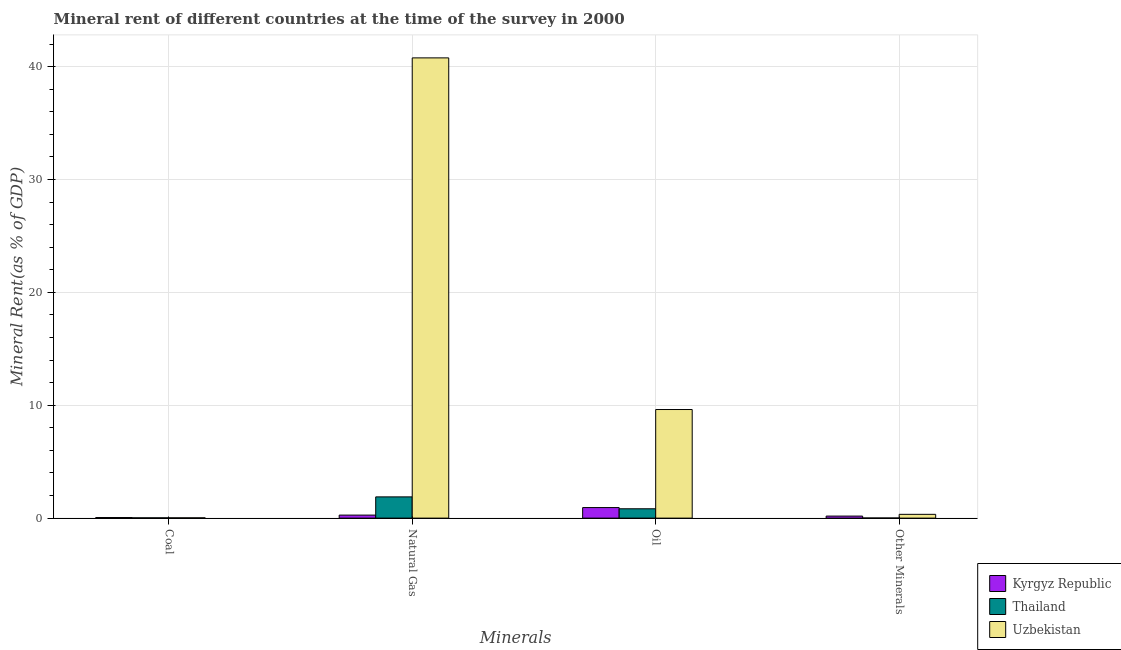How many different coloured bars are there?
Offer a terse response. 3. How many groups of bars are there?
Your answer should be compact. 4. Are the number of bars per tick equal to the number of legend labels?
Your answer should be very brief. Yes. Are the number of bars on each tick of the X-axis equal?
Your response must be concise. Yes. What is the label of the 3rd group of bars from the left?
Your answer should be very brief. Oil. What is the natural gas rent in Uzbekistan?
Provide a short and direct response. 40.78. Across all countries, what is the maximum coal rent?
Your answer should be very brief. 0.05. Across all countries, what is the minimum oil rent?
Make the answer very short. 0.83. In which country was the oil rent maximum?
Offer a very short reply. Uzbekistan. In which country was the oil rent minimum?
Offer a terse response. Thailand. What is the total  rent of other minerals in the graph?
Offer a terse response. 0.52. What is the difference between the natural gas rent in Thailand and that in Uzbekistan?
Your response must be concise. -38.9. What is the difference between the oil rent in Uzbekistan and the  rent of other minerals in Kyrgyz Republic?
Your answer should be very brief. 9.44. What is the average natural gas rent per country?
Offer a very short reply. 14.31. What is the difference between the  rent of other minerals and natural gas rent in Kyrgyz Republic?
Offer a very short reply. -0.09. In how many countries, is the oil rent greater than 36 %?
Ensure brevity in your answer.  0. What is the ratio of the oil rent in Thailand to that in Uzbekistan?
Your response must be concise. 0.09. Is the difference between the natural gas rent in Uzbekistan and Kyrgyz Republic greater than the difference between the coal rent in Uzbekistan and Kyrgyz Republic?
Your answer should be compact. Yes. What is the difference between the highest and the second highest oil rent?
Your response must be concise. 8.69. What is the difference between the highest and the lowest oil rent?
Your answer should be compact. 8.79. In how many countries, is the  rent of other minerals greater than the average  rent of other minerals taken over all countries?
Your answer should be compact. 2. What does the 2nd bar from the left in Oil represents?
Offer a very short reply. Thailand. What does the 3rd bar from the right in Oil represents?
Offer a very short reply. Kyrgyz Republic. Is it the case that in every country, the sum of the coal rent and natural gas rent is greater than the oil rent?
Make the answer very short. No. How many bars are there?
Provide a succinct answer. 12. What is the difference between two consecutive major ticks on the Y-axis?
Make the answer very short. 10. How many legend labels are there?
Your answer should be compact. 3. How are the legend labels stacked?
Ensure brevity in your answer.  Vertical. What is the title of the graph?
Keep it short and to the point. Mineral rent of different countries at the time of the survey in 2000. Does "Swaziland" appear as one of the legend labels in the graph?
Your answer should be very brief. No. What is the label or title of the X-axis?
Give a very brief answer. Minerals. What is the label or title of the Y-axis?
Offer a very short reply. Mineral Rent(as % of GDP). What is the Mineral Rent(as % of GDP) in Kyrgyz Republic in Coal?
Offer a terse response. 0.05. What is the Mineral Rent(as % of GDP) of Thailand in Coal?
Your answer should be very brief. 0.03. What is the Mineral Rent(as % of GDP) of Uzbekistan in Coal?
Ensure brevity in your answer.  0.03. What is the Mineral Rent(as % of GDP) of Kyrgyz Republic in Natural Gas?
Your answer should be compact. 0.27. What is the Mineral Rent(as % of GDP) of Thailand in Natural Gas?
Provide a succinct answer. 1.88. What is the Mineral Rent(as % of GDP) of Uzbekistan in Natural Gas?
Your response must be concise. 40.78. What is the Mineral Rent(as % of GDP) of Kyrgyz Republic in Oil?
Give a very brief answer. 0.94. What is the Mineral Rent(as % of GDP) of Thailand in Oil?
Offer a very short reply. 0.83. What is the Mineral Rent(as % of GDP) of Uzbekistan in Oil?
Offer a very short reply. 9.62. What is the Mineral Rent(as % of GDP) in Kyrgyz Republic in Other Minerals?
Your answer should be compact. 0.18. What is the Mineral Rent(as % of GDP) in Thailand in Other Minerals?
Ensure brevity in your answer.  0.01. What is the Mineral Rent(as % of GDP) in Uzbekistan in Other Minerals?
Keep it short and to the point. 0.34. Across all Minerals, what is the maximum Mineral Rent(as % of GDP) of Kyrgyz Republic?
Provide a succinct answer. 0.94. Across all Minerals, what is the maximum Mineral Rent(as % of GDP) in Thailand?
Your response must be concise. 1.88. Across all Minerals, what is the maximum Mineral Rent(as % of GDP) of Uzbekistan?
Your response must be concise. 40.78. Across all Minerals, what is the minimum Mineral Rent(as % of GDP) in Kyrgyz Republic?
Your response must be concise. 0.05. Across all Minerals, what is the minimum Mineral Rent(as % of GDP) in Thailand?
Keep it short and to the point. 0.01. Across all Minerals, what is the minimum Mineral Rent(as % of GDP) of Uzbekistan?
Offer a terse response. 0.03. What is the total Mineral Rent(as % of GDP) in Kyrgyz Republic in the graph?
Provide a short and direct response. 1.43. What is the total Mineral Rent(as % of GDP) of Thailand in the graph?
Your answer should be very brief. 2.74. What is the total Mineral Rent(as % of GDP) of Uzbekistan in the graph?
Provide a short and direct response. 50.77. What is the difference between the Mineral Rent(as % of GDP) of Kyrgyz Republic in Coal and that in Natural Gas?
Your answer should be very brief. -0.22. What is the difference between the Mineral Rent(as % of GDP) in Thailand in Coal and that in Natural Gas?
Your answer should be very brief. -1.86. What is the difference between the Mineral Rent(as % of GDP) in Uzbekistan in Coal and that in Natural Gas?
Offer a terse response. -40.76. What is the difference between the Mineral Rent(as % of GDP) in Kyrgyz Republic in Coal and that in Oil?
Your answer should be very brief. -0.88. What is the difference between the Mineral Rent(as % of GDP) of Thailand in Coal and that in Oil?
Provide a succinct answer. -0.8. What is the difference between the Mineral Rent(as % of GDP) in Uzbekistan in Coal and that in Oil?
Your response must be concise. -9.6. What is the difference between the Mineral Rent(as % of GDP) in Kyrgyz Republic in Coal and that in Other Minerals?
Your answer should be compact. -0.13. What is the difference between the Mineral Rent(as % of GDP) of Thailand in Coal and that in Other Minerals?
Offer a terse response. 0.02. What is the difference between the Mineral Rent(as % of GDP) in Uzbekistan in Coal and that in Other Minerals?
Provide a succinct answer. -0.31. What is the difference between the Mineral Rent(as % of GDP) in Kyrgyz Republic in Natural Gas and that in Oil?
Make the answer very short. -0.67. What is the difference between the Mineral Rent(as % of GDP) of Thailand in Natural Gas and that in Oil?
Offer a very short reply. 1.05. What is the difference between the Mineral Rent(as % of GDP) of Uzbekistan in Natural Gas and that in Oil?
Provide a succinct answer. 31.16. What is the difference between the Mineral Rent(as % of GDP) of Kyrgyz Republic in Natural Gas and that in Other Minerals?
Give a very brief answer. 0.09. What is the difference between the Mineral Rent(as % of GDP) of Thailand in Natural Gas and that in Other Minerals?
Your answer should be very brief. 1.87. What is the difference between the Mineral Rent(as % of GDP) of Uzbekistan in Natural Gas and that in Other Minerals?
Your response must be concise. 40.45. What is the difference between the Mineral Rent(as % of GDP) of Kyrgyz Republic in Oil and that in Other Minerals?
Ensure brevity in your answer.  0.76. What is the difference between the Mineral Rent(as % of GDP) of Thailand in Oil and that in Other Minerals?
Keep it short and to the point. 0.82. What is the difference between the Mineral Rent(as % of GDP) of Uzbekistan in Oil and that in Other Minerals?
Your response must be concise. 9.29. What is the difference between the Mineral Rent(as % of GDP) in Kyrgyz Republic in Coal and the Mineral Rent(as % of GDP) in Thailand in Natural Gas?
Give a very brief answer. -1.83. What is the difference between the Mineral Rent(as % of GDP) of Kyrgyz Republic in Coal and the Mineral Rent(as % of GDP) of Uzbekistan in Natural Gas?
Your answer should be compact. -40.73. What is the difference between the Mineral Rent(as % of GDP) in Thailand in Coal and the Mineral Rent(as % of GDP) in Uzbekistan in Natural Gas?
Make the answer very short. -40.76. What is the difference between the Mineral Rent(as % of GDP) of Kyrgyz Republic in Coal and the Mineral Rent(as % of GDP) of Thailand in Oil?
Give a very brief answer. -0.78. What is the difference between the Mineral Rent(as % of GDP) of Kyrgyz Republic in Coal and the Mineral Rent(as % of GDP) of Uzbekistan in Oil?
Offer a terse response. -9.57. What is the difference between the Mineral Rent(as % of GDP) in Thailand in Coal and the Mineral Rent(as % of GDP) in Uzbekistan in Oil?
Give a very brief answer. -9.6. What is the difference between the Mineral Rent(as % of GDP) in Kyrgyz Republic in Coal and the Mineral Rent(as % of GDP) in Thailand in Other Minerals?
Your answer should be compact. 0.04. What is the difference between the Mineral Rent(as % of GDP) of Kyrgyz Republic in Coal and the Mineral Rent(as % of GDP) of Uzbekistan in Other Minerals?
Your answer should be very brief. -0.28. What is the difference between the Mineral Rent(as % of GDP) of Thailand in Coal and the Mineral Rent(as % of GDP) of Uzbekistan in Other Minerals?
Provide a short and direct response. -0.31. What is the difference between the Mineral Rent(as % of GDP) of Kyrgyz Republic in Natural Gas and the Mineral Rent(as % of GDP) of Thailand in Oil?
Your response must be concise. -0.56. What is the difference between the Mineral Rent(as % of GDP) of Kyrgyz Republic in Natural Gas and the Mineral Rent(as % of GDP) of Uzbekistan in Oil?
Keep it short and to the point. -9.35. What is the difference between the Mineral Rent(as % of GDP) of Thailand in Natural Gas and the Mineral Rent(as % of GDP) of Uzbekistan in Oil?
Offer a terse response. -7.74. What is the difference between the Mineral Rent(as % of GDP) in Kyrgyz Republic in Natural Gas and the Mineral Rent(as % of GDP) in Thailand in Other Minerals?
Your answer should be very brief. 0.26. What is the difference between the Mineral Rent(as % of GDP) of Kyrgyz Republic in Natural Gas and the Mineral Rent(as % of GDP) of Uzbekistan in Other Minerals?
Keep it short and to the point. -0.07. What is the difference between the Mineral Rent(as % of GDP) of Thailand in Natural Gas and the Mineral Rent(as % of GDP) of Uzbekistan in Other Minerals?
Your answer should be compact. 1.55. What is the difference between the Mineral Rent(as % of GDP) of Kyrgyz Republic in Oil and the Mineral Rent(as % of GDP) of Thailand in Other Minerals?
Your answer should be very brief. 0.93. What is the difference between the Mineral Rent(as % of GDP) in Kyrgyz Republic in Oil and the Mineral Rent(as % of GDP) in Uzbekistan in Other Minerals?
Provide a succinct answer. 0.6. What is the difference between the Mineral Rent(as % of GDP) of Thailand in Oil and the Mineral Rent(as % of GDP) of Uzbekistan in Other Minerals?
Make the answer very short. 0.49. What is the average Mineral Rent(as % of GDP) of Kyrgyz Republic per Minerals?
Give a very brief answer. 0.36. What is the average Mineral Rent(as % of GDP) of Thailand per Minerals?
Keep it short and to the point. 0.69. What is the average Mineral Rent(as % of GDP) of Uzbekistan per Minerals?
Offer a very short reply. 12.69. What is the difference between the Mineral Rent(as % of GDP) of Kyrgyz Republic and Mineral Rent(as % of GDP) of Thailand in Coal?
Your answer should be compact. 0.03. What is the difference between the Mineral Rent(as % of GDP) in Kyrgyz Republic and Mineral Rent(as % of GDP) in Uzbekistan in Coal?
Ensure brevity in your answer.  0.03. What is the difference between the Mineral Rent(as % of GDP) of Thailand and Mineral Rent(as % of GDP) of Uzbekistan in Coal?
Give a very brief answer. -0. What is the difference between the Mineral Rent(as % of GDP) of Kyrgyz Republic and Mineral Rent(as % of GDP) of Thailand in Natural Gas?
Provide a succinct answer. -1.61. What is the difference between the Mineral Rent(as % of GDP) of Kyrgyz Republic and Mineral Rent(as % of GDP) of Uzbekistan in Natural Gas?
Offer a very short reply. -40.52. What is the difference between the Mineral Rent(as % of GDP) of Thailand and Mineral Rent(as % of GDP) of Uzbekistan in Natural Gas?
Offer a terse response. -38.9. What is the difference between the Mineral Rent(as % of GDP) in Kyrgyz Republic and Mineral Rent(as % of GDP) in Thailand in Oil?
Your response must be concise. 0.11. What is the difference between the Mineral Rent(as % of GDP) of Kyrgyz Republic and Mineral Rent(as % of GDP) of Uzbekistan in Oil?
Your response must be concise. -8.69. What is the difference between the Mineral Rent(as % of GDP) in Thailand and Mineral Rent(as % of GDP) in Uzbekistan in Oil?
Your answer should be compact. -8.79. What is the difference between the Mineral Rent(as % of GDP) in Kyrgyz Republic and Mineral Rent(as % of GDP) in Thailand in Other Minerals?
Offer a very short reply. 0.17. What is the difference between the Mineral Rent(as % of GDP) in Kyrgyz Republic and Mineral Rent(as % of GDP) in Uzbekistan in Other Minerals?
Give a very brief answer. -0.16. What is the difference between the Mineral Rent(as % of GDP) in Thailand and Mineral Rent(as % of GDP) in Uzbekistan in Other Minerals?
Your response must be concise. -0.33. What is the ratio of the Mineral Rent(as % of GDP) of Kyrgyz Republic in Coal to that in Natural Gas?
Your answer should be very brief. 0.19. What is the ratio of the Mineral Rent(as % of GDP) of Thailand in Coal to that in Natural Gas?
Make the answer very short. 0.01. What is the ratio of the Mineral Rent(as % of GDP) in Uzbekistan in Coal to that in Natural Gas?
Offer a terse response. 0. What is the ratio of the Mineral Rent(as % of GDP) in Kyrgyz Republic in Coal to that in Oil?
Your response must be concise. 0.05. What is the ratio of the Mineral Rent(as % of GDP) in Thailand in Coal to that in Oil?
Offer a terse response. 0.03. What is the ratio of the Mineral Rent(as % of GDP) in Uzbekistan in Coal to that in Oil?
Make the answer very short. 0. What is the ratio of the Mineral Rent(as % of GDP) in Kyrgyz Republic in Coal to that in Other Minerals?
Provide a succinct answer. 0.28. What is the ratio of the Mineral Rent(as % of GDP) of Thailand in Coal to that in Other Minerals?
Provide a succinct answer. 2.59. What is the ratio of the Mineral Rent(as % of GDP) in Uzbekistan in Coal to that in Other Minerals?
Give a very brief answer. 0.08. What is the ratio of the Mineral Rent(as % of GDP) of Kyrgyz Republic in Natural Gas to that in Oil?
Offer a terse response. 0.29. What is the ratio of the Mineral Rent(as % of GDP) of Thailand in Natural Gas to that in Oil?
Your answer should be very brief. 2.27. What is the ratio of the Mineral Rent(as % of GDP) in Uzbekistan in Natural Gas to that in Oil?
Make the answer very short. 4.24. What is the ratio of the Mineral Rent(as % of GDP) in Kyrgyz Republic in Natural Gas to that in Other Minerals?
Ensure brevity in your answer.  1.49. What is the ratio of the Mineral Rent(as % of GDP) in Thailand in Natural Gas to that in Other Minerals?
Give a very brief answer. 192.81. What is the ratio of the Mineral Rent(as % of GDP) in Uzbekistan in Natural Gas to that in Other Minerals?
Give a very brief answer. 121.68. What is the ratio of the Mineral Rent(as % of GDP) of Kyrgyz Republic in Oil to that in Other Minerals?
Provide a short and direct response. 5.2. What is the ratio of the Mineral Rent(as % of GDP) of Thailand in Oil to that in Other Minerals?
Keep it short and to the point. 84.9. What is the ratio of the Mineral Rent(as % of GDP) of Uzbekistan in Oil to that in Other Minerals?
Your response must be concise. 28.71. What is the difference between the highest and the second highest Mineral Rent(as % of GDP) in Kyrgyz Republic?
Offer a terse response. 0.67. What is the difference between the highest and the second highest Mineral Rent(as % of GDP) of Thailand?
Your response must be concise. 1.05. What is the difference between the highest and the second highest Mineral Rent(as % of GDP) in Uzbekistan?
Your answer should be very brief. 31.16. What is the difference between the highest and the lowest Mineral Rent(as % of GDP) in Kyrgyz Republic?
Provide a succinct answer. 0.88. What is the difference between the highest and the lowest Mineral Rent(as % of GDP) in Thailand?
Offer a very short reply. 1.87. What is the difference between the highest and the lowest Mineral Rent(as % of GDP) in Uzbekistan?
Your response must be concise. 40.76. 